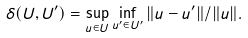<formula> <loc_0><loc_0><loc_500><loc_500>\delta ( U , U ^ { \prime } ) = \sup _ { u \in U } \inf _ { u ^ { \prime } \in U ^ { \prime } } \| u - u ^ { \prime } \| / \| u \| .</formula> 